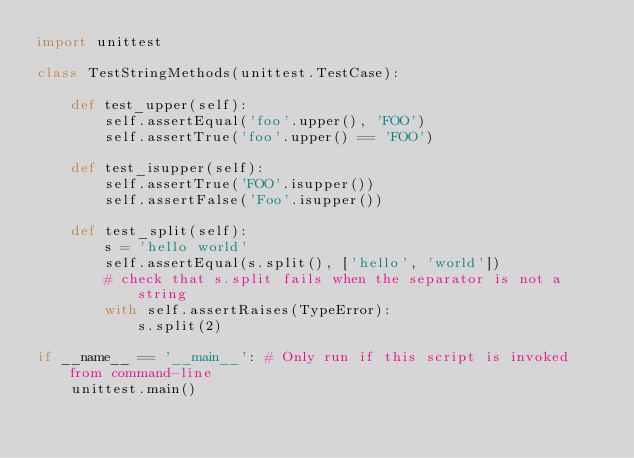<code> <loc_0><loc_0><loc_500><loc_500><_Python_>import unittest

class TestStringMethods(unittest.TestCase):

    def test_upper(self):
        self.assertEqual('foo'.upper(), 'FOO')
        self.assertTrue('foo'.upper() == 'FOO')

    def test_isupper(self):
        self.assertTrue('FOO'.isupper())
        self.assertFalse('Foo'.isupper())

    def test_split(self):
        s = 'hello world'
        self.assertEqual(s.split(), ['hello', 'world'])
        # check that s.split fails when the separator is not a string
        with self.assertRaises(TypeError):
            s.split(2)

if __name__ == '__main__': # Only run if this script is invoked from command-line
    unittest.main()</code> 